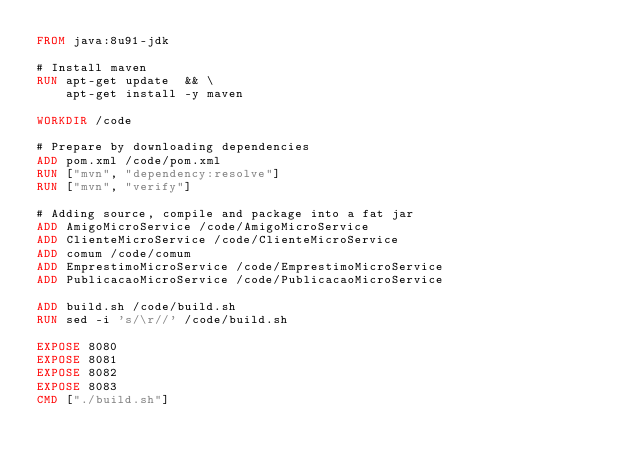Convert code to text. <code><loc_0><loc_0><loc_500><loc_500><_Dockerfile_>FROM java:8u91-jdk

# Install maven
RUN apt-get update  && \
    apt-get install -y maven

WORKDIR /code

# Prepare by downloading dependencies
ADD pom.xml /code/pom.xml  
RUN ["mvn", "dependency:resolve"]  
RUN ["mvn", "verify"]

# Adding source, compile and package into a fat jar
ADD AmigoMicroService /code/AmigoMicroService  
ADD ClienteMicroService /code/ClienteMicroService
ADD comum /code/comum
ADD EmprestimoMicroService /code/EmprestimoMicroService
ADD PublicacaoMicroService /code/PublicacaoMicroService
 
ADD build.sh /code/build.sh
RUN sed -i 's/\r//' /code/build.sh

EXPOSE 8080
EXPOSE 8081
EXPOSE 8082
EXPOSE 8083  
CMD ["./build.sh"] </code> 